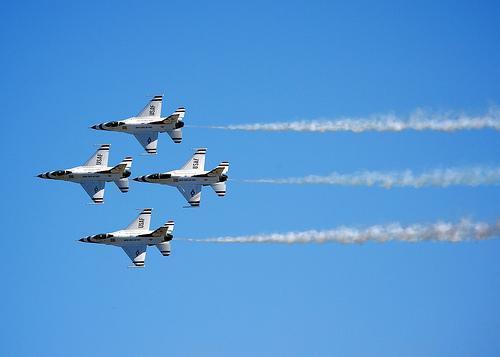How many airplanes are in the sky?
Give a very brief answer. 4. 